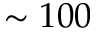Convert formula to latex. <formula><loc_0><loc_0><loc_500><loc_500>\sim 1 0 0</formula> 